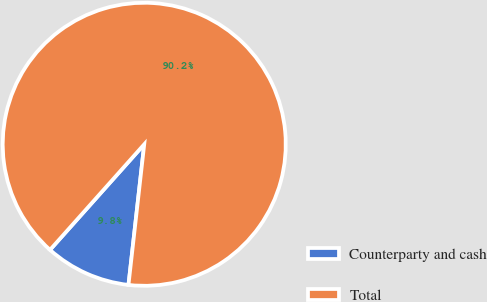Convert chart to OTSL. <chart><loc_0><loc_0><loc_500><loc_500><pie_chart><fcel>Counterparty and cash<fcel>Total<nl><fcel>9.82%<fcel>90.18%<nl></chart> 